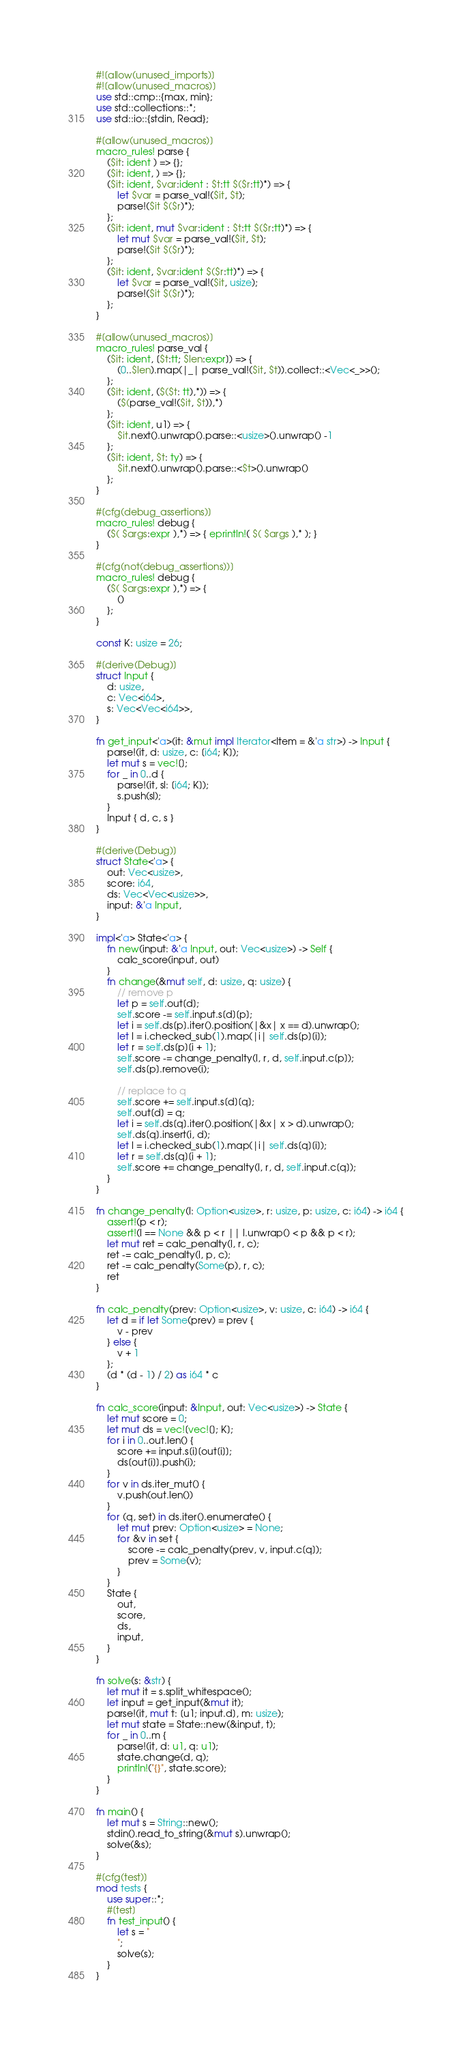<code> <loc_0><loc_0><loc_500><loc_500><_Rust_>#![allow(unused_imports)]
#![allow(unused_macros)]
use std::cmp::{max, min};
use std::collections::*;
use std::io::{stdin, Read};

#[allow(unused_macros)]
macro_rules! parse {
    ($it: ident ) => {};
    ($it: ident, ) => {};
    ($it: ident, $var:ident : $t:tt $($r:tt)*) => {
        let $var = parse_val!($it, $t);
        parse!($it $($r)*);
    };
    ($it: ident, mut $var:ident : $t:tt $($r:tt)*) => {
        let mut $var = parse_val!($it, $t);
        parse!($it $($r)*);
    };
    ($it: ident, $var:ident $($r:tt)*) => {
        let $var = parse_val!($it, usize);
        parse!($it $($r)*);
    };
}

#[allow(unused_macros)]
macro_rules! parse_val {
    ($it: ident, [$t:tt; $len:expr]) => {
        (0..$len).map(|_| parse_val!($it, $t)).collect::<Vec<_>>();
    };
    ($it: ident, ($($t: tt),*)) => {
        ($(parse_val!($it, $t)),*)
    };
    ($it: ident, u1) => {
        $it.next().unwrap().parse::<usize>().unwrap() -1
    };
    ($it: ident, $t: ty) => {
        $it.next().unwrap().parse::<$t>().unwrap()
    };
}

#[cfg(debug_assertions)]
macro_rules! debug {
    ($( $args:expr ),*) => { eprintln!( $( $args ),* ); }
}

#[cfg(not(debug_assertions))]
macro_rules! debug {
    ($( $args:expr ),*) => {
        ()
    };
}

const K: usize = 26;

#[derive(Debug)]
struct Input {
    d: usize,
    c: Vec<i64>,
    s: Vec<Vec<i64>>,
}

fn get_input<'a>(it: &mut impl Iterator<Item = &'a str>) -> Input {
    parse!(it, d: usize, c: [i64; K]);
    let mut s = vec![];
    for _ in 0..d {
        parse!(it, sl: [i64; K]);
        s.push(sl);
    }
    Input { d, c, s }
}

#[derive(Debug)]
struct State<'a> {
    out: Vec<usize>,
    score: i64,
    ds: Vec<Vec<usize>>,
    input: &'a Input,
}

impl<'a> State<'a> {
    fn new(input: &'a Input, out: Vec<usize>) -> Self {
        calc_score(input, out)
    }
    fn change(&mut self, d: usize, q: usize) {
        // remove p
        let p = self.out[d];
        self.score -= self.input.s[d][p];
        let i = self.ds[p].iter().position(|&x| x == d).unwrap();
        let l = i.checked_sub(1).map(|i| self.ds[p][i]);
        let r = self.ds[p][i + 1];
        self.score -= change_penalty(l, r, d, self.input.c[p]);
        self.ds[p].remove(i);

        // replace to q
        self.score += self.input.s[d][q];
        self.out[d] = q;
        let i = self.ds[q].iter().position(|&x| x > d).unwrap();
        self.ds[q].insert(i, d);
        let l = i.checked_sub(1).map(|i| self.ds[q][i]);
        let r = self.ds[q][i + 1];
        self.score += change_penalty(l, r, d, self.input.c[q]);
    }
}

fn change_penalty(l: Option<usize>, r: usize, p: usize, c: i64) -> i64 {
    assert!(p < r);
    assert!(l == None && p < r || l.unwrap() < p && p < r);
    let mut ret = calc_penalty(l, r, c);
    ret -= calc_penalty(l, p, c);
    ret -= calc_penalty(Some(p), r, c);
    ret
}

fn calc_penalty(prev: Option<usize>, v: usize, c: i64) -> i64 {
    let d = if let Some(prev) = prev {
        v - prev
    } else {
        v + 1
    };
    (d * (d - 1) / 2) as i64 * c
}

fn calc_score(input: &Input, out: Vec<usize>) -> State {
    let mut score = 0;
    let mut ds = vec![vec![]; K];
    for i in 0..out.len() {
        score += input.s[i][out[i]];
        ds[out[i]].push(i);
    }
    for v in ds.iter_mut() {
        v.push(out.len())
    }
    for (q, set) in ds.iter().enumerate() {
        let mut prev: Option<usize> = None;
        for &v in set {
            score -= calc_penalty(prev, v, input.c[q]);
            prev = Some(v);
        }
    }
    State {
        out,
        score,
        ds,
        input,
    }
}

fn solve(s: &str) {
    let mut it = s.split_whitespace();
    let input = get_input(&mut it);
    parse!(it, mut t: [u1; input.d], m: usize);
    let mut state = State::new(&input, t);
    for _ in 0..m {
        parse!(it, d: u1, q: u1);
        state.change(d, q);
        println!("{}", state.score);
    }
}

fn main() {
    let mut s = String::new();
    stdin().read_to_string(&mut s).unwrap();
    solve(&s);
}

#[cfg(test)]
mod tests {
    use super::*;
    #[test]
    fn test_input() {
        let s = "
        ";
        solve(s);
    }
}
</code> 